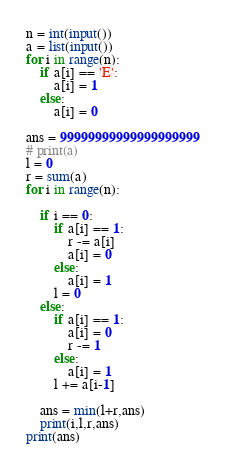<code> <loc_0><loc_0><loc_500><loc_500><_Python_>n = int(input())
a = list(input())
for i in range(n):
    if a[i] == 'E':
        a[i] = 1
    else:
        a[i] = 0

ans = 99999999999999999999
# print(a)
l = 0
r = sum(a)
for i in range(n):

    if i == 0:
        if a[i] == 1:
            r -= a[i]
            a[i] = 0
        else:
            a[i] = 1
        l = 0
    else:
        if a[i] == 1:
            a[i] = 0
            r -= 1
        else:
            a[i] = 1
        l += a[i-1]

    ans = min(l+r,ans)
    print(i,l,r,ans)
print(ans)

</code> 